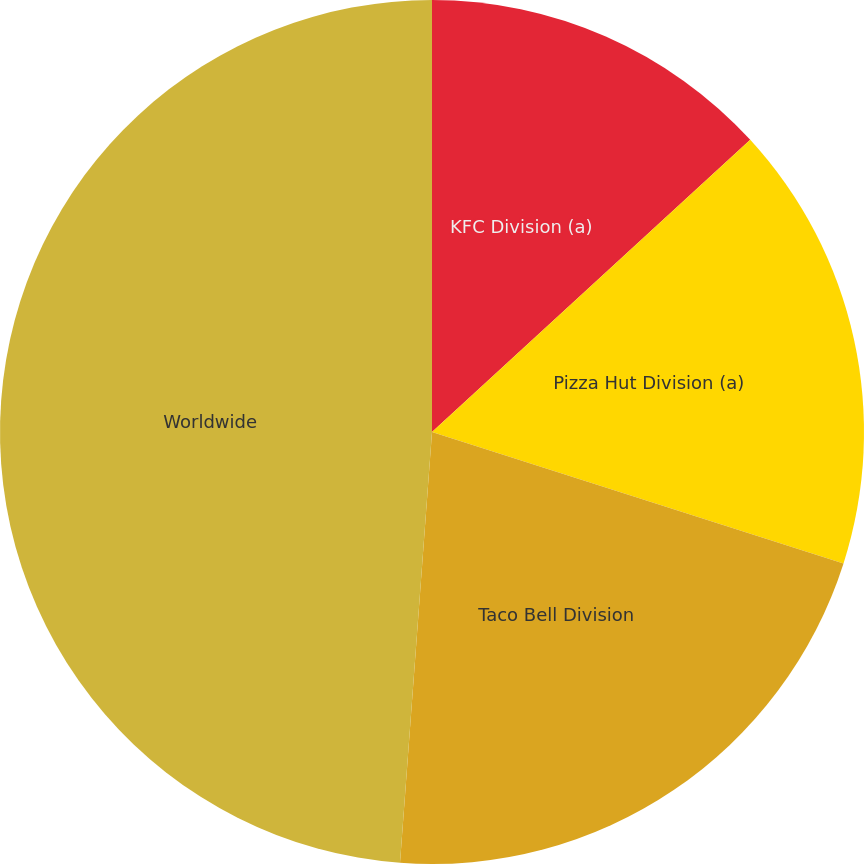Convert chart to OTSL. <chart><loc_0><loc_0><loc_500><loc_500><pie_chart><fcel>KFC Division (a)<fcel>Pizza Hut Division (a)<fcel>Taco Bell Division<fcel>Worldwide<nl><fcel>13.18%<fcel>16.74%<fcel>21.26%<fcel>48.82%<nl></chart> 